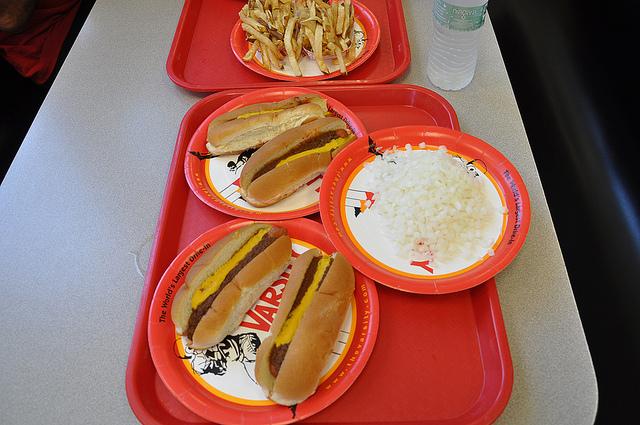What is on the hot dogs?
Quick response, please. Mustard. How many food trays are there?
Concise answer only. 2. Is the meal for a toddler or adult?
Concise answer only. Adult. What is the white food?
Short answer required. Rice. Is this a well-balanced meal?
Be succinct. No. Would you like to have a meal like that?
Give a very brief answer. Yes. 